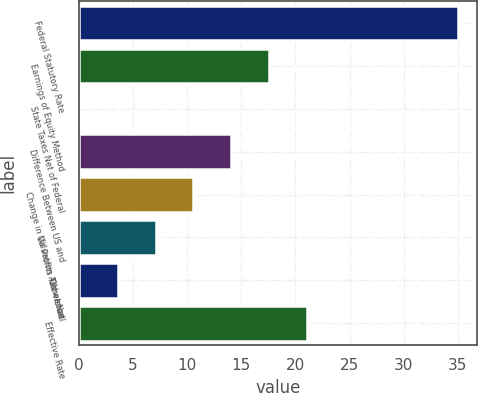Convert chart to OTSL. <chart><loc_0><loc_0><loc_500><loc_500><bar_chart><fcel>Federal Statutory Rate<fcel>Earnings of Equity Method<fcel>State Taxes Net of Federal<fcel>Difference Between US and<fcel>Change in Valuation Allowance<fcel>Oil Profits Tax - Israel<fcel>Other Net<fcel>Effective Rate<nl><fcel>35<fcel>17.55<fcel>0.1<fcel>14.06<fcel>10.57<fcel>7.08<fcel>3.59<fcel>21.04<nl></chart> 